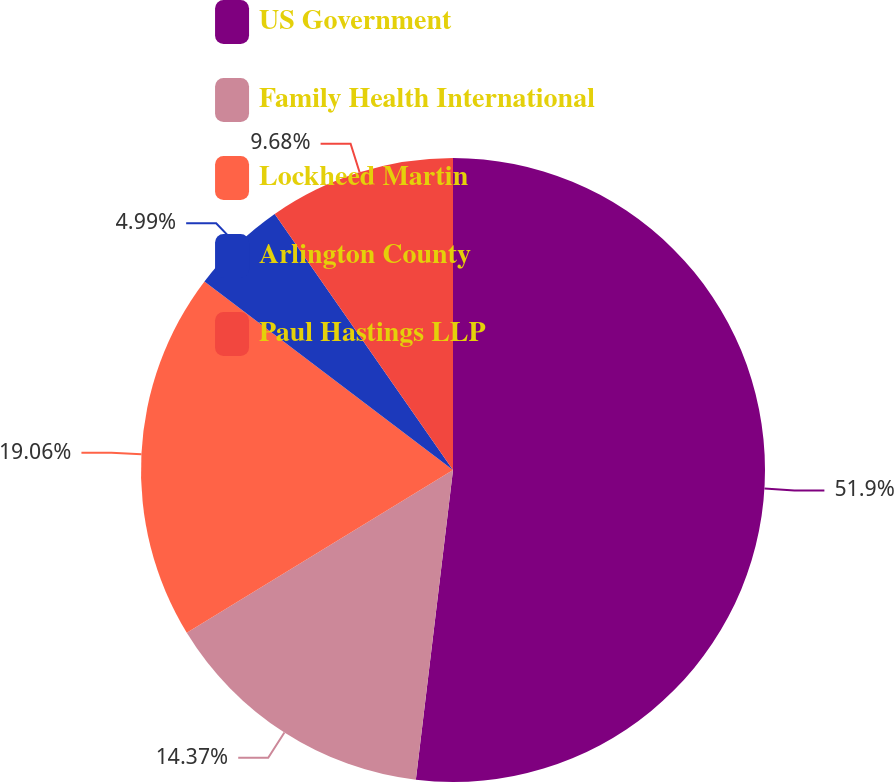Convert chart to OTSL. <chart><loc_0><loc_0><loc_500><loc_500><pie_chart><fcel>US Government<fcel>Family Health International<fcel>Lockheed Martin<fcel>Arlington County<fcel>Paul Hastings LLP<nl><fcel>51.9%<fcel>14.37%<fcel>19.06%<fcel>4.99%<fcel>9.68%<nl></chart> 